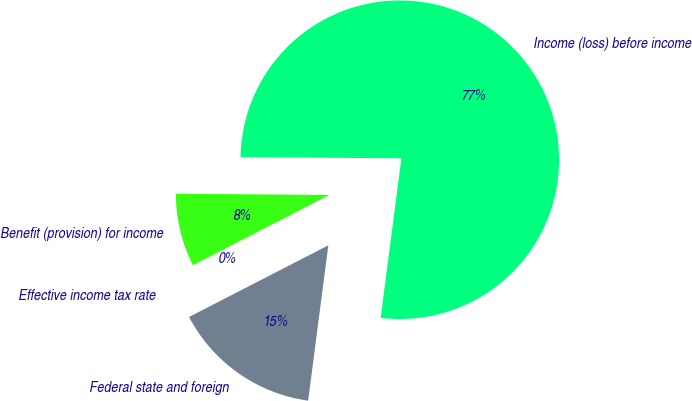<chart> <loc_0><loc_0><loc_500><loc_500><pie_chart><fcel>Income (loss) before income<fcel>Benefit (provision) for income<fcel>Effective income tax rate<fcel>Federal state and foreign<nl><fcel>76.92%<fcel>7.69%<fcel>0.0%<fcel>15.38%<nl></chart> 